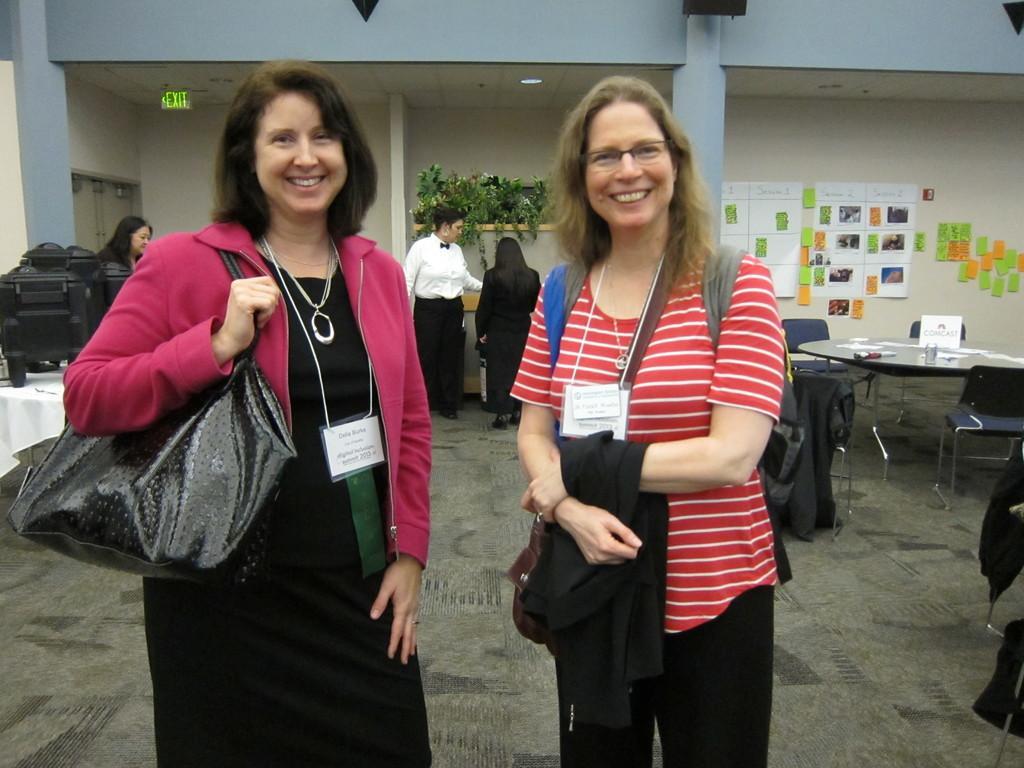How would you summarize this image in a sentence or two? This picture shows two men Standing and a woman holding a handbag in hand and we see two people standing on the back and we see a table and couple of chairs and we see posters on the wall 